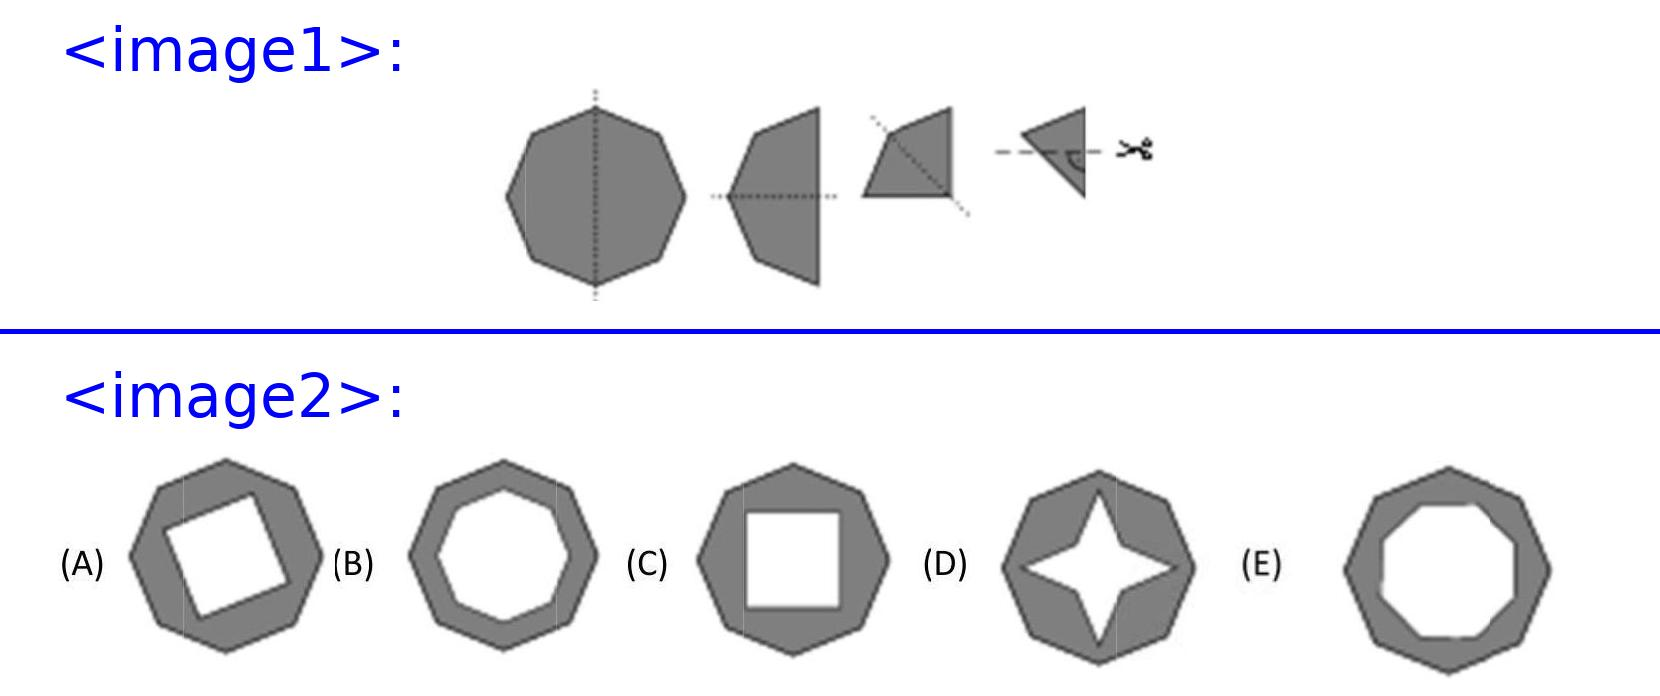A regular octagon is folded three times down the middle as shown, until a triangle is formed. Then the rightmost corner is cut away. Which of the following shapes is formed when the paper is unfolded? After assessing the process visually, when the paper, originally a regular octagon, is folded down to a triangle and the rightmost corner is trimmed, upon unfolding, each folding line will mirror the cut symmetrically across all segments. The resulting shape would resemble option C, which showcases an octagonal shape with alternating sides slightly concaved inwards due to the replicated triangular cuts across the structure. 